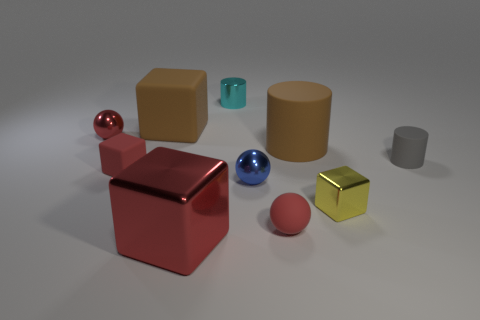Subtract all large brown matte cubes. How many cubes are left? 3 Subtract 1 spheres. How many spheres are left? 2 Subtract all balls. How many objects are left? 7 Add 2 big red metal objects. How many big red metal objects are left? 3 Add 3 tiny cyan shiny cylinders. How many tiny cyan shiny cylinders exist? 4 Subtract all brown cylinders. How many cylinders are left? 2 Subtract 1 brown cylinders. How many objects are left? 9 Subtract all red cubes. Subtract all blue cylinders. How many cubes are left? 2 Subtract all green cubes. How many red spheres are left? 2 Subtract all red matte cubes. Subtract all large red metal objects. How many objects are left? 8 